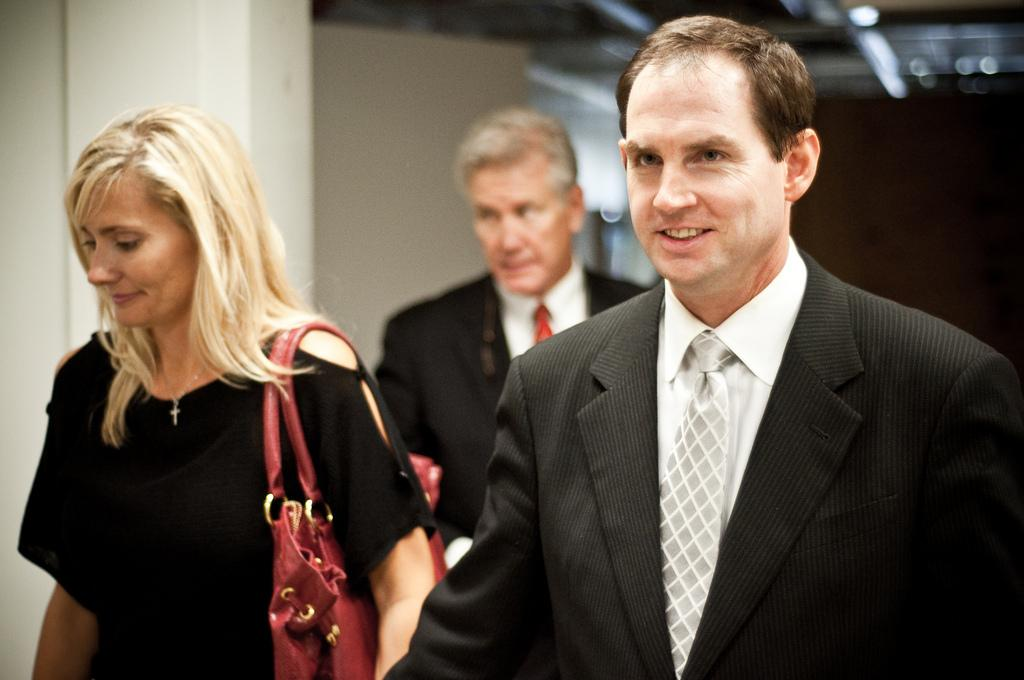How many people are in the image? There are people in the image, but the exact number is not specified. What is one of the people wearing? One of the people is wearing a bag. What can be seen in the background of the image? There are lights and a wall visible in the background. How many quills are being used by the woman in the image? There is no woman or quills present in the image. What is the amount of money being exchanged between the people in the image? The facts provided do not mention any exchange of money or any financial transactions taking place in the image. 